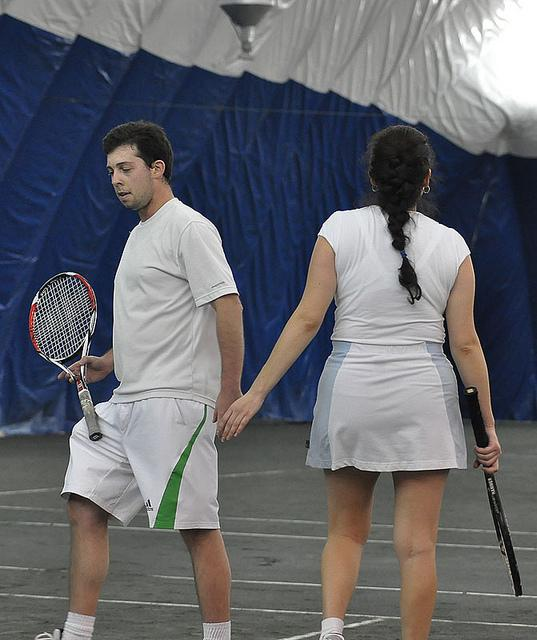What is making the man's pocket pop up? Please explain your reasoning. tennis balls. The people are holding rackets. 